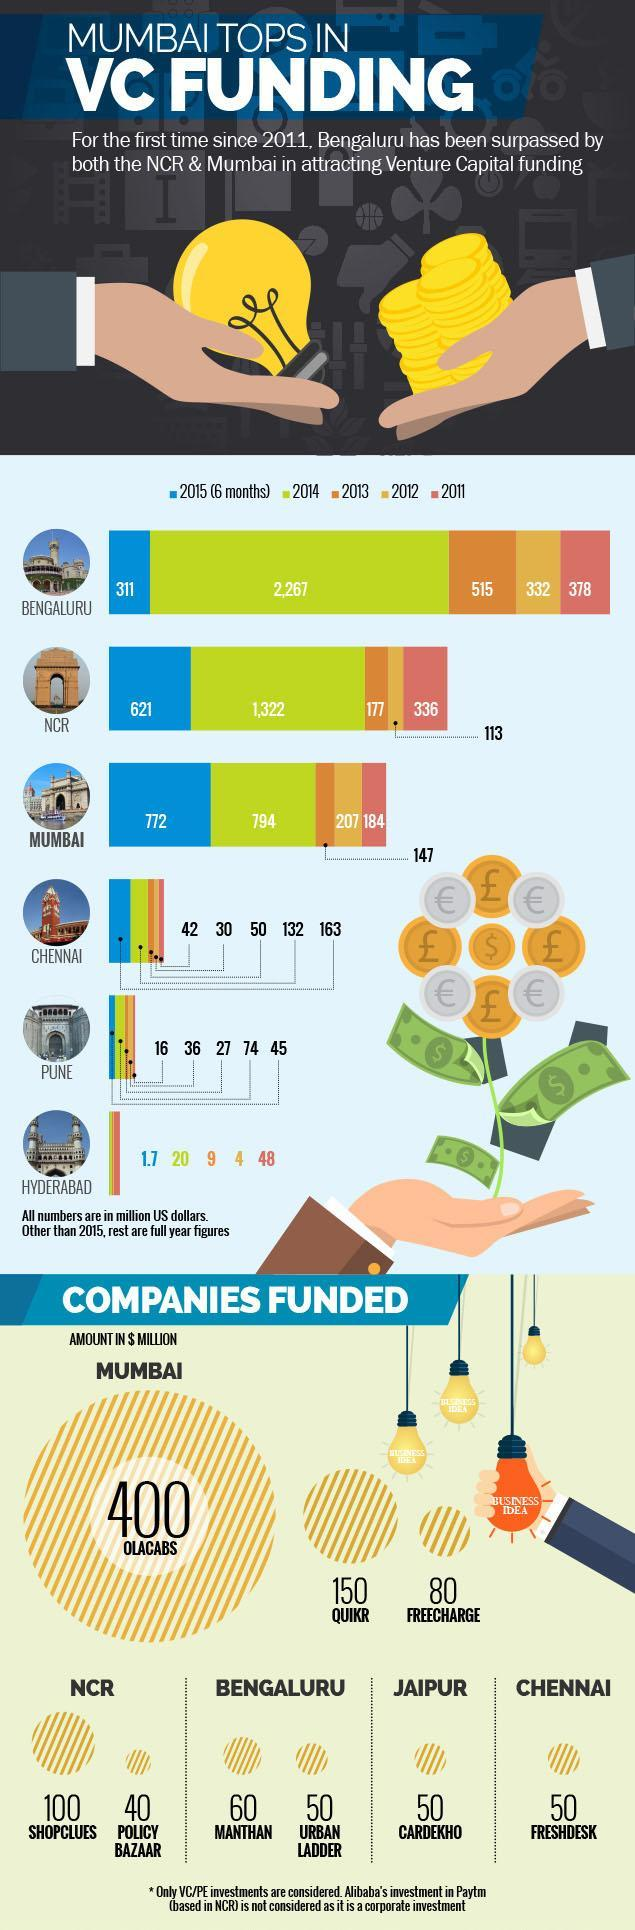How much money was attracted as Venture capital during 2011 in Bengaluru?
Answer the question with a short phrase. 378 million US dollars Which year is represented by green colour? 2014 What amount was funded in the year 2013 in Mumbai? 147 million US dollars 